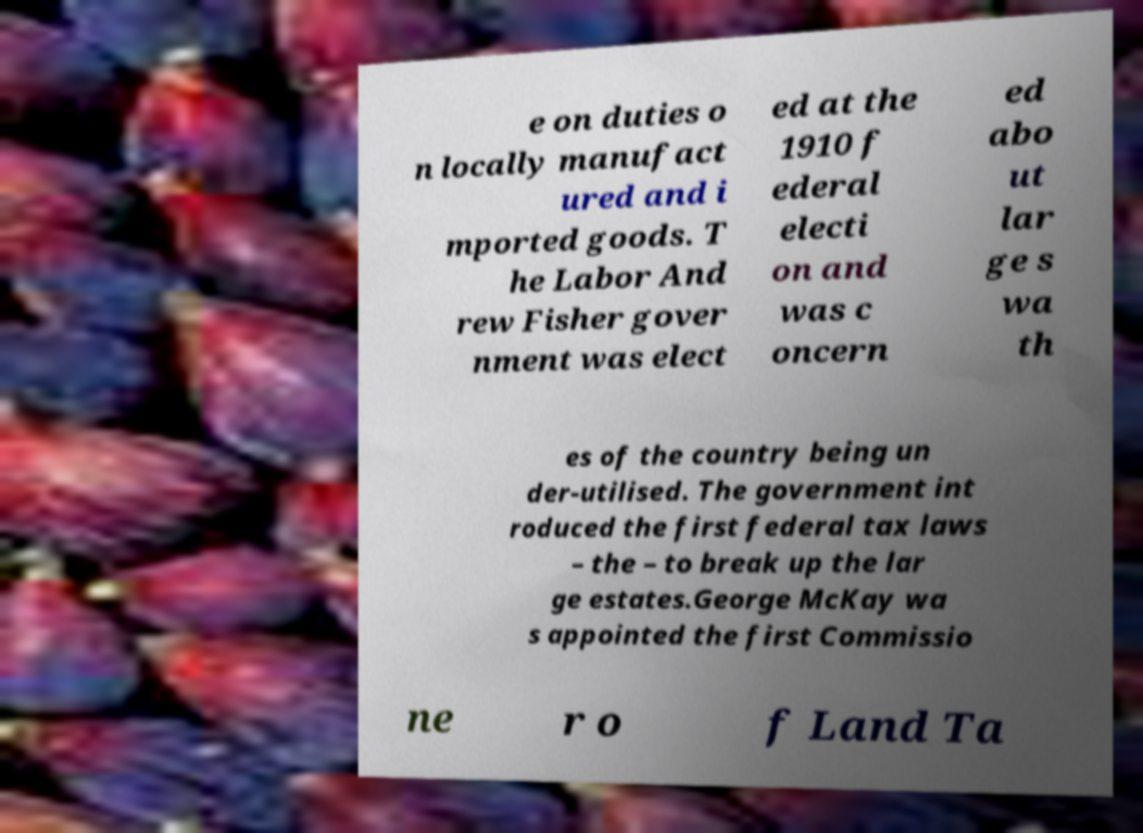Can you accurately transcribe the text from the provided image for me? e on duties o n locally manufact ured and i mported goods. T he Labor And rew Fisher gover nment was elect ed at the 1910 f ederal electi on and was c oncern ed abo ut lar ge s wa th es of the country being un der-utilised. The government int roduced the first federal tax laws – the – to break up the lar ge estates.George McKay wa s appointed the first Commissio ne r o f Land Ta 